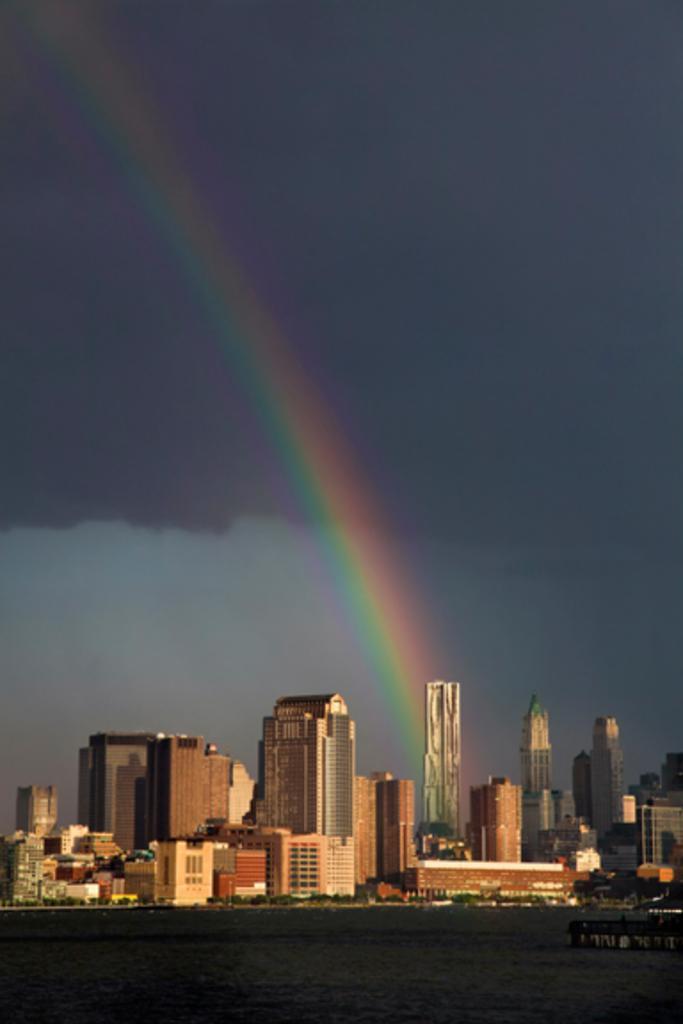Please provide a concise description of this image. On the bottom we can see skyscrapers, buildings and road. Here we can see a boat on the water. Here we can see rainbow. On the top we can see sky and clouds. 